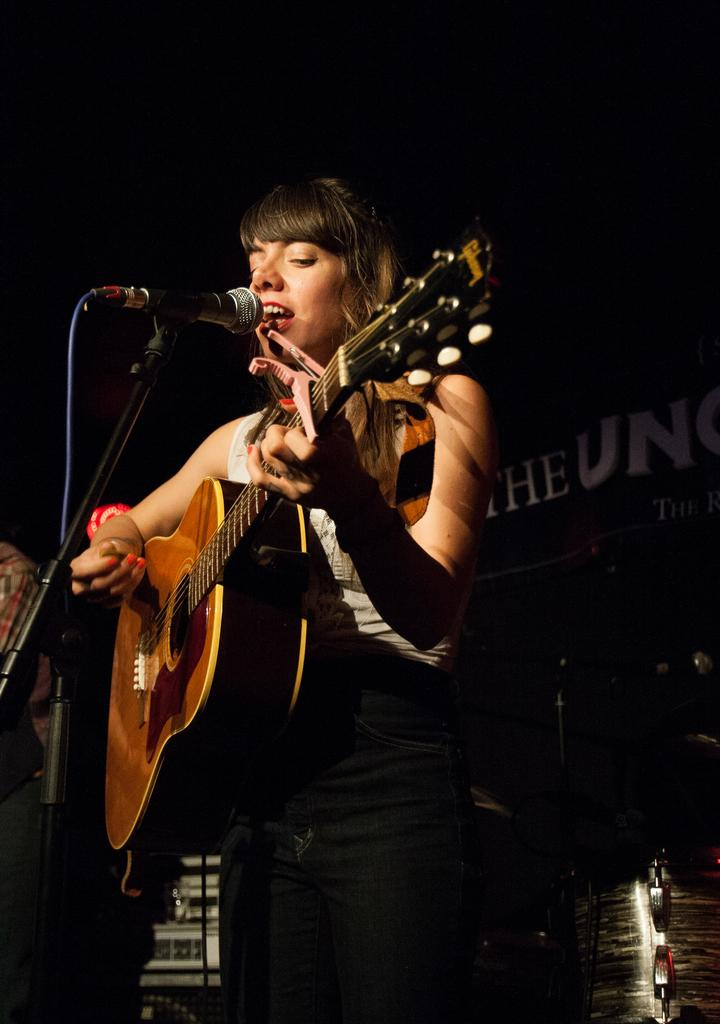Who is the main subject in the image? There is a woman in the image. What is the woman doing in the image? The woman is standing, singing, and playing a guitar. What object is present in the image that is commonly used for amplifying sound? There is a microphone in the image. Can you see any popcorn floating on the lake near the woman in the image? There is no lake or popcorn present in the image. What type of flower is the woman holding while playing the guitar? The woman is not holding a flower in the image; she is playing a guitar. 